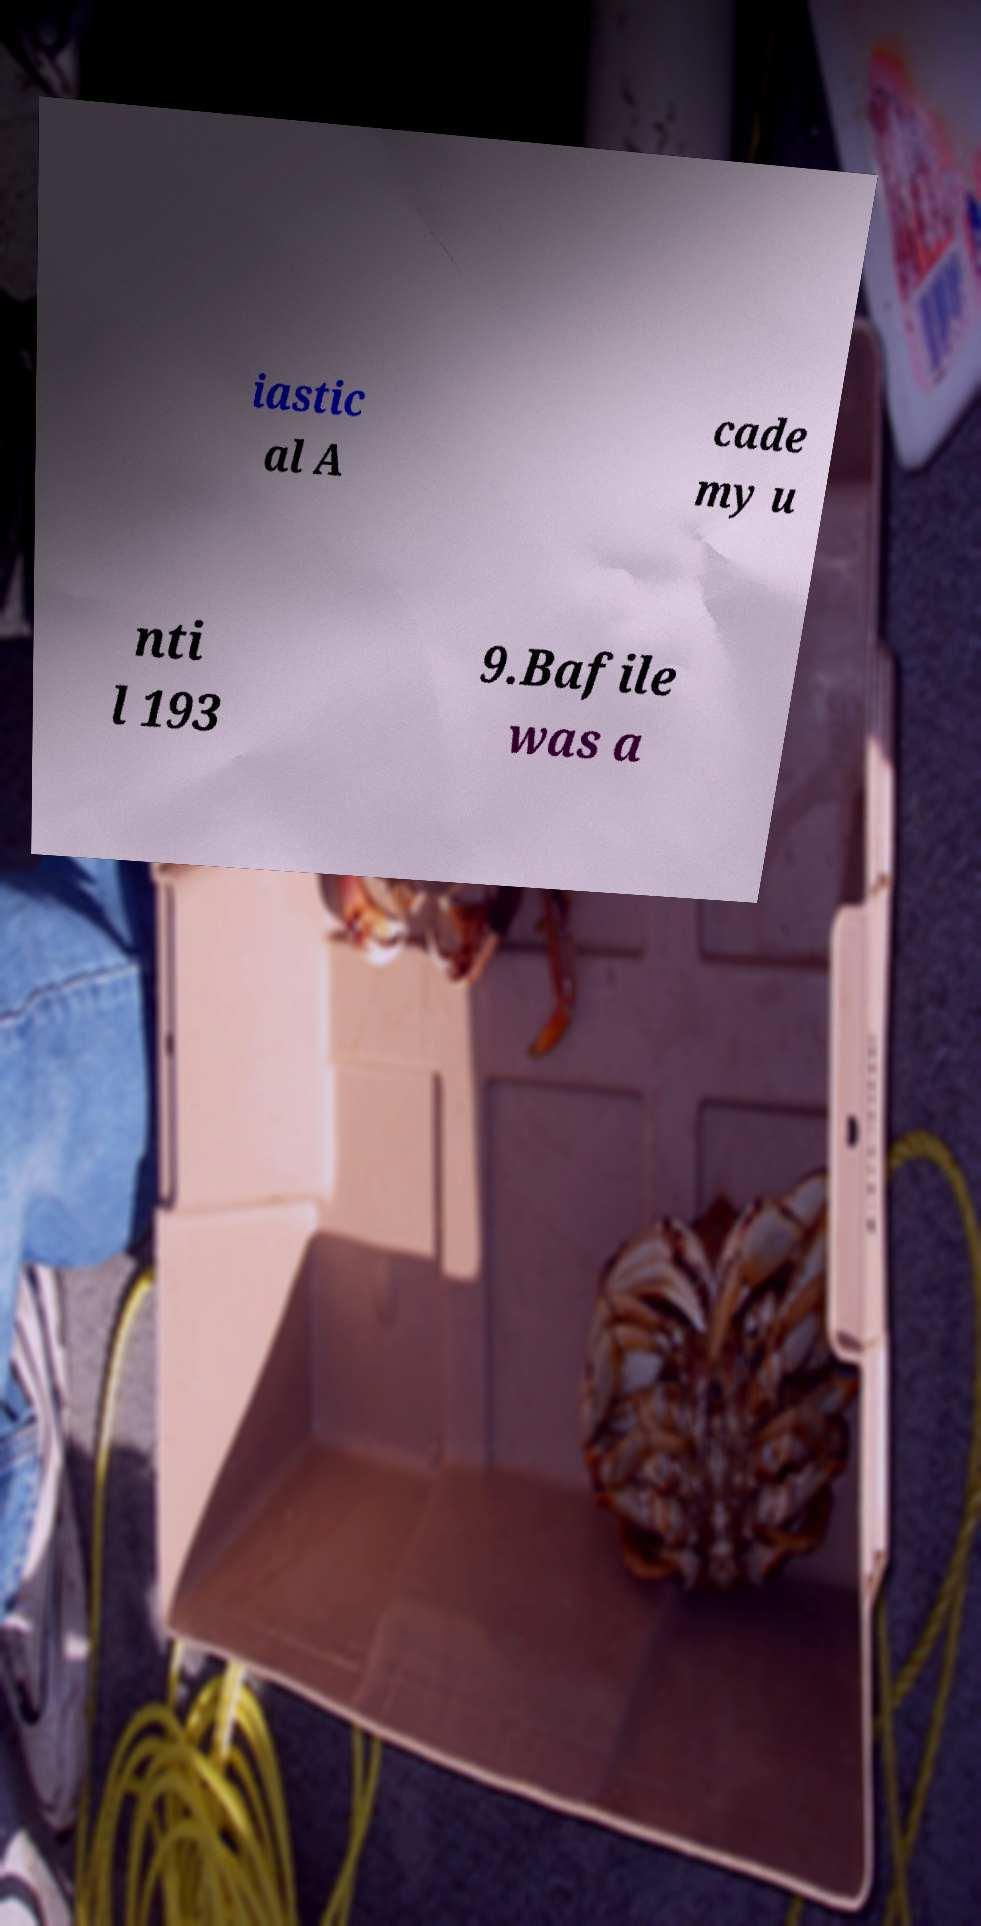For documentation purposes, I need the text within this image transcribed. Could you provide that? iastic al A cade my u nti l 193 9.Bafile was a 